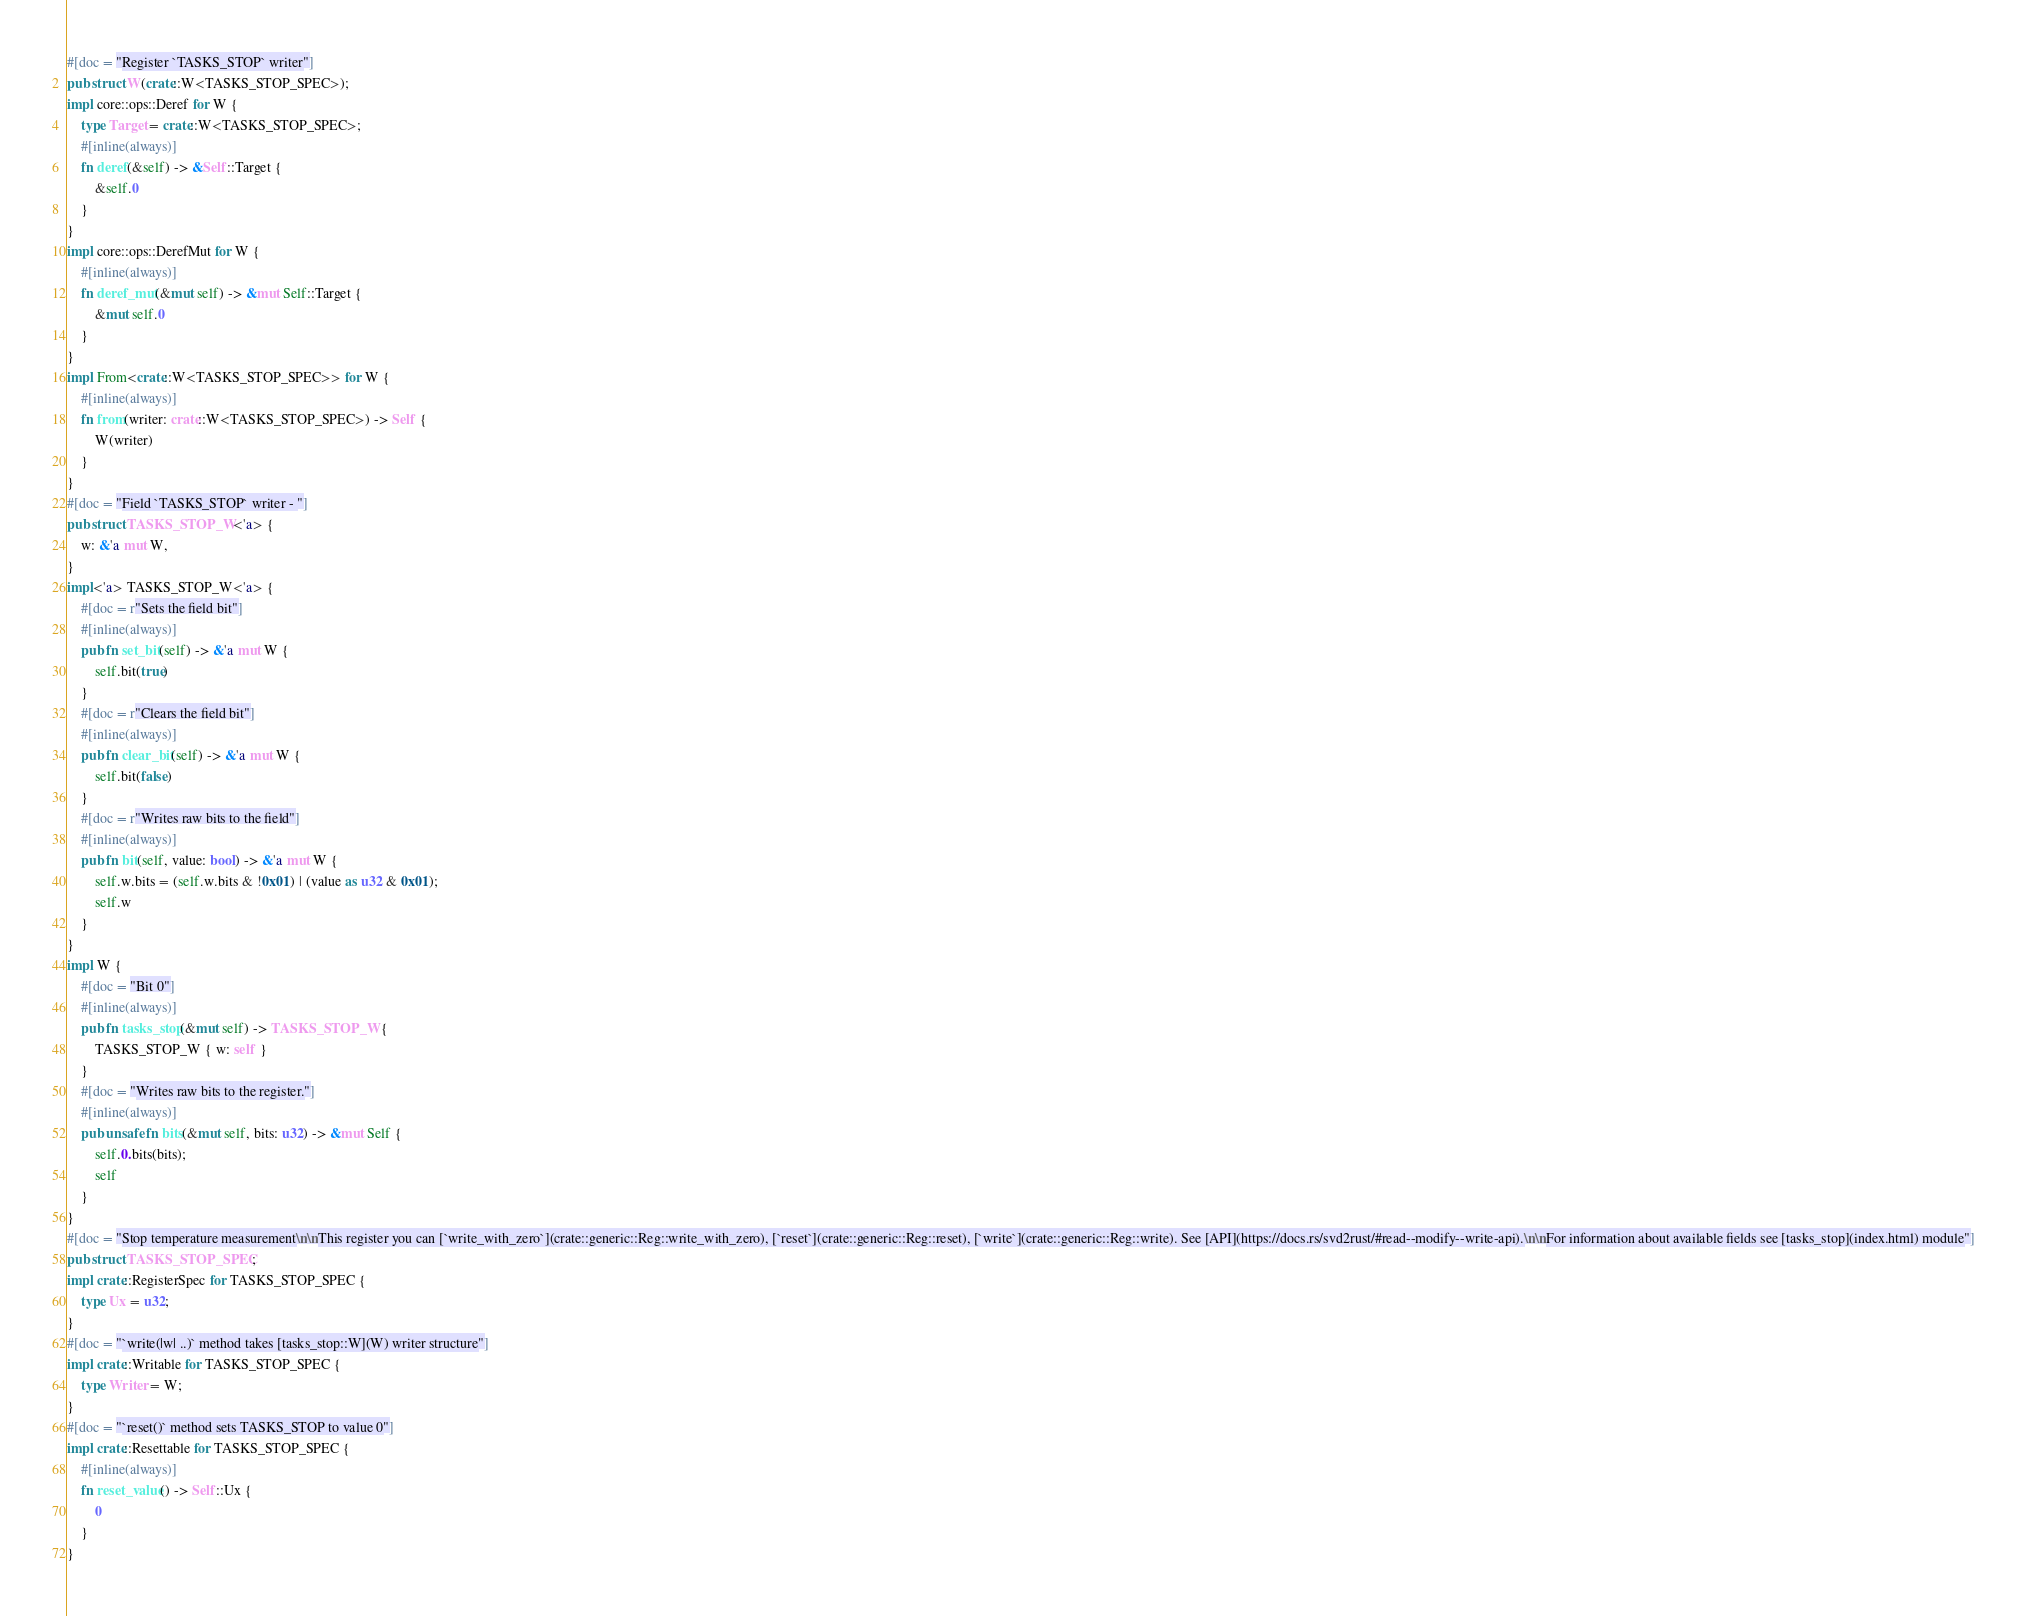Convert code to text. <code><loc_0><loc_0><loc_500><loc_500><_Rust_>#[doc = "Register `TASKS_STOP` writer"]
pub struct W(crate::W<TASKS_STOP_SPEC>);
impl core::ops::Deref for W {
    type Target = crate::W<TASKS_STOP_SPEC>;
    #[inline(always)]
    fn deref(&self) -> &Self::Target {
        &self.0
    }
}
impl core::ops::DerefMut for W {
    #[inline(always)]
    fn deref_mut(&mut self) -> &mut Self::Target {
        &mut self.0
    }
}
impl From<crate::W<TASKS_STOP_SPEC>> for W {
    #[inline(always)]
    fn from(writer: crate::W<TASKS_STOP_SPEC>) -> Self {
        W(writer)
    }
}
#[doc = "Field `TASKS_STOP` writer - "]
pub struct TASKS_STOP_W<'a> {
    w: &'a mut W,
}
impl<'a> TASKS_STOP_W<'a> {
    #[doc = r"Sets the field bit"]
    #[inline(always)]
    pub fn set_bit(self) -> &'a mut W {
        self.bit(true)
    }
    #[doc = r"Clears the field bit"]
    #[inline(always)]
    pub fn clear_bit(self) -> &'a mut W {
        self.bit(false)
    }
    #[doc = r"Writes raw bits to the field"]
    #[inline(always)]
    pub fn bit(self, value: bool) -> &'a mut W {
        self.w.bits = (self.w.bits & !0x01) | (value as u32 & 0x01);
        self.w
    }
}
impl W {
    #[doc = "Bit 0"]
    #[inline(always)]
    pub fn tasks_stop(&mut self) -> TASKS_STOP_W {
        TASKS_STOP_W { w: self }
    }
    #[doc = "Writes raw bits to the register."]
    #[inline(always)]
    pub unsafe fn bits(&mut self, bits: u32) -> &mut Self {
        self.0.bits(bits);
        self
    }
}
#[doc = "Stop temperature measurement\n\nThis register you can [`write_with_zero`](crate::generic::Reg::write_with_zero), [`reset`](crate::generic::Reg::reset), [`write`](crate::generic::Reg::write). See [API](https://docs.rs/svd2rust/#read--modify--write-api).\n\nFor information about available fields see [tasks_stop](index.html) module"]
pub struct TASKS_STOP_SPEC;
impl crate::RegisterSpec for TASKS_STOP_SPEC {
    type Ux = u32;
}
#[doc = "`write(|w| ..)` method takes [tasks_stop::W](W) writer structure"]
impl crate::Writable for TASKS_STOP_SPEC {
    type Writer = W;
}
#[doc = "`reset()` method sets TASKS_STOP to value 0"]
impl crate::Resettable for TASKS_STOP_SPEC {
    #[inline(always)]
    fn reset_value() -> Self::Ux {
        0
    }
}
</code> 